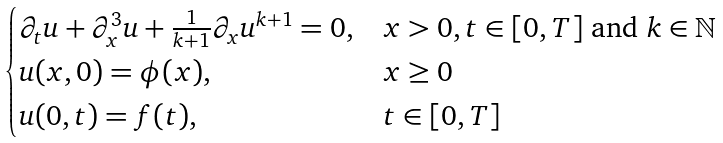<formula> <loc_0><loc_0><loc_500><loc_500>\begin{cases} \partial _ { t } u + \partial _ { x } ^ { 3 } u + \frac { 1 } { k + 1 } \partial _ { x } u ^ { k + 1 } = 0 , & x > 0 , t \in [ 0 , T ] \text { and } k \in { \mathbb { N } } \\ u ( x , 0 ) = \phi ( x ) , & x \geq 0 \\ u ( 0 , t ) = f ( t ) , & t \in [ 0 , T ] \end{cases}</formula> 